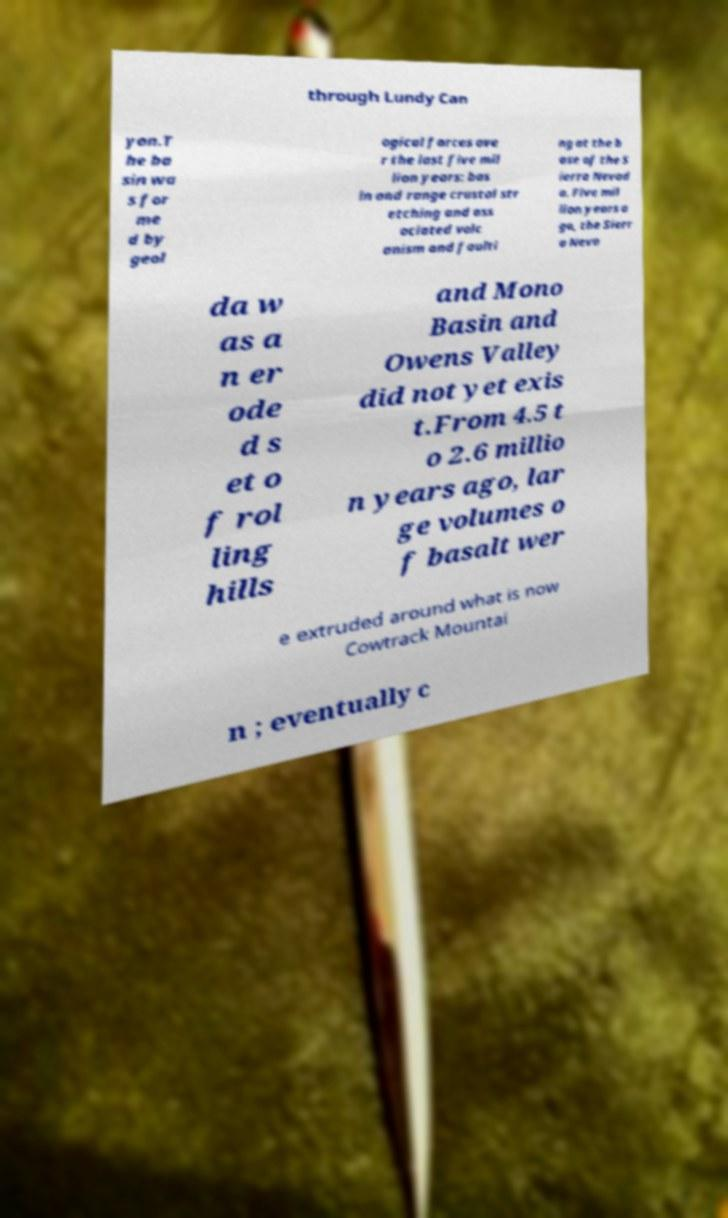Could you assist in decoding the text presented in this image and type it out clearly? through Lundy Can yon.T he ba sin wa s for me d by geol ogical forces ove r the last five mil lion years: bas in and range crustal str etching and ass ociated volc anism and faulti ng at the b ase of the S ierra Nevad a. Five mil lion years a go, the Sierr a Neva da w as a n er ode d s et o f rol ling hills and Mono Basin and Owens Valley did not yet exis t.From 4.5 t o 2.6 millio n years ago, lar ge volumes o f basalt wer e extruded around what is now Cowtrack Mountai n ; eventually c 